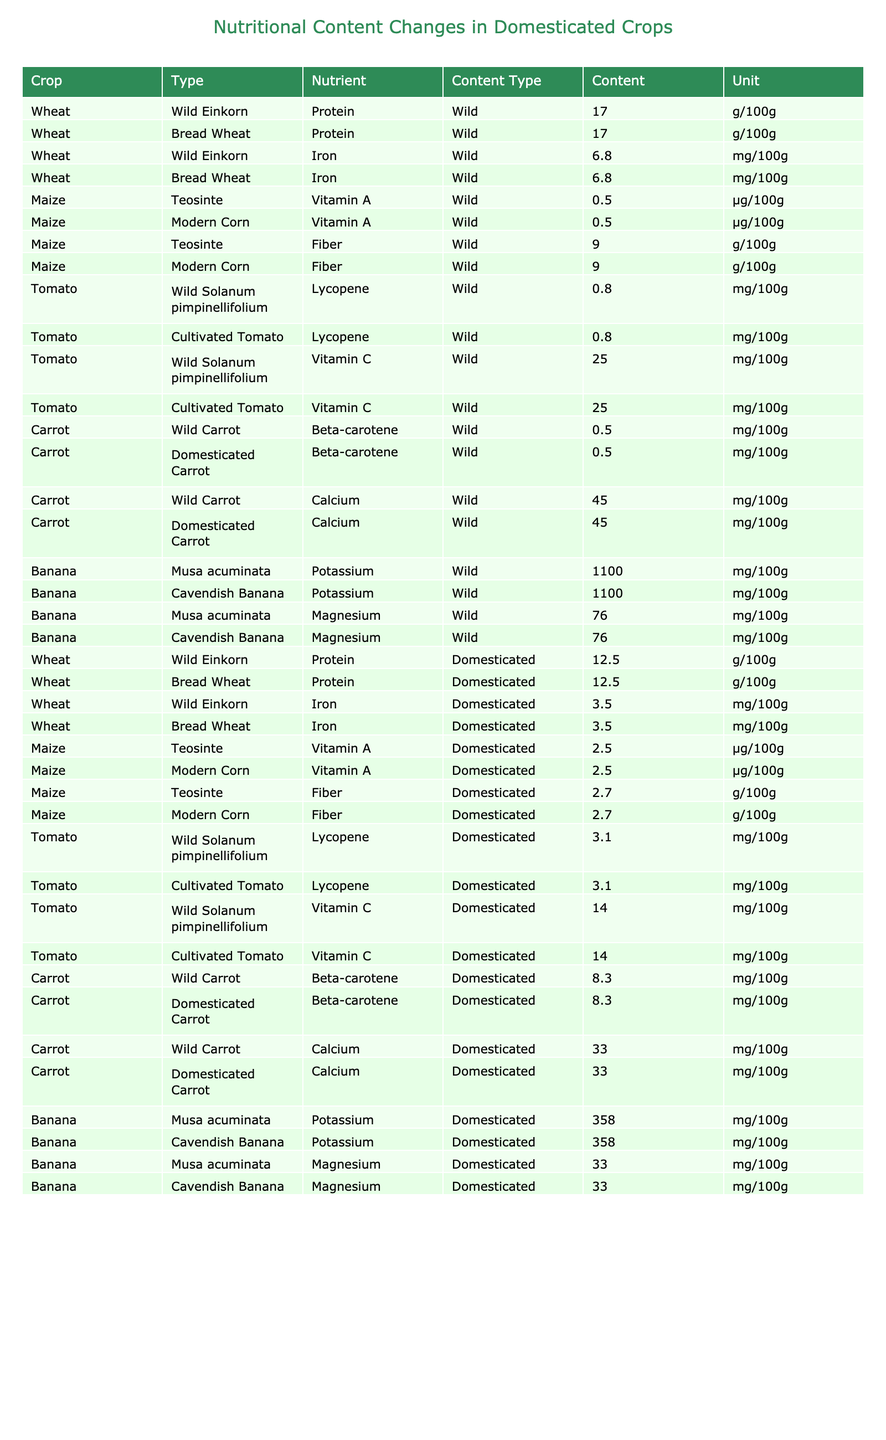What is the protein content of domesticated wheat? In the table, the entry for both Wild Einkorn and Bread Wheat shows the protein content for domesticated wheat, which is 12.5 g/100g.
Answer: 12.5 g/100g How much iron is present in domesticated wheat compared to its wild ancestor? The table lists the iron content for both Wild Einkorn and Bread Wheat as 3.5 mg/100g for domesticated wheat and 6.8 mg/100g for wild einkorn, showing that domesticated wheat has less iron.
Answer: 3.5 mg/100g (domesticated) vs 6.8 mg/100g (wild) Which crop has the highest beta-carotene content in its domesticated form? According to the table, domesticated carrot has 8.3 mg/100g of beta-carotene, which is the highest compared to the values for other domesticated crops listed.
Answer: Domesticated carrot What is the difference in potassium content between wild and domesticated bananas? From the table, wild Musa acuminata has a potassium content of 1100 mg/100g and domesticated Cavendish banana has 358 mg/100g. The difference is 1100 - 358 = 742 mg/100g.
Answer: 742 mg/100g True or false: Domesticated tomatoes have higher lycopene content than their wild ancestors. The table indicates both cultivated and wild tomatoes have a lycopene content of 3.1 mg/100g, thus domesticated tomatoes do not have higher lycopene than wild ones.
Answer: False Which nutrient in domesticated maize has a lower content compared to its wild ancestor? The table shows that the fiber content for both Teosinte (wild maize) is 9.0 g/100g and Modern Corn (domesticated maize) is 2.7 g/100g. Thus, domesticated maize has lower fiber.
Answer: Fiber What is the average vitamin C content for the two types of tomatoes listed? The table shows both types of tomatoes have 14.0 mg/100g for domesticated and 25.0 mg/100g for wild; thus, average vitamin C = (14.0 + 25.0) / 2 = 19.5 mg/100g.
Answer: 19.5 mg/100g What crop shows the most substantial decrease in magnesium content from wild to domesticated form? The table shows wild Musa acuminata with 76.0 mg/100g of magnesium significantly drops to 33.0 mg/100g in Cavendish banana, indicating the most considerable decrease.
Answer: Banana (Cavendish) Which cultivated crop has the lowest iron content based on the data? Looking at the table, both domesticated wheat and cultivated maize have the same iron content of 3.5 mg/100g, indicating the lowest iron content among cultivated crops listed.
Answer: Wheat and maize (3.5 mg/100g) How does the calcium content in domesticated carrots compare to its wild counterpart? The data lists wild carrot with 45.0 mg/100g of calcium and domesticated carrot with 33.0 mg/100g, indicating domesticated carrots have lower calcium content.
Answer: Lower calcium content 